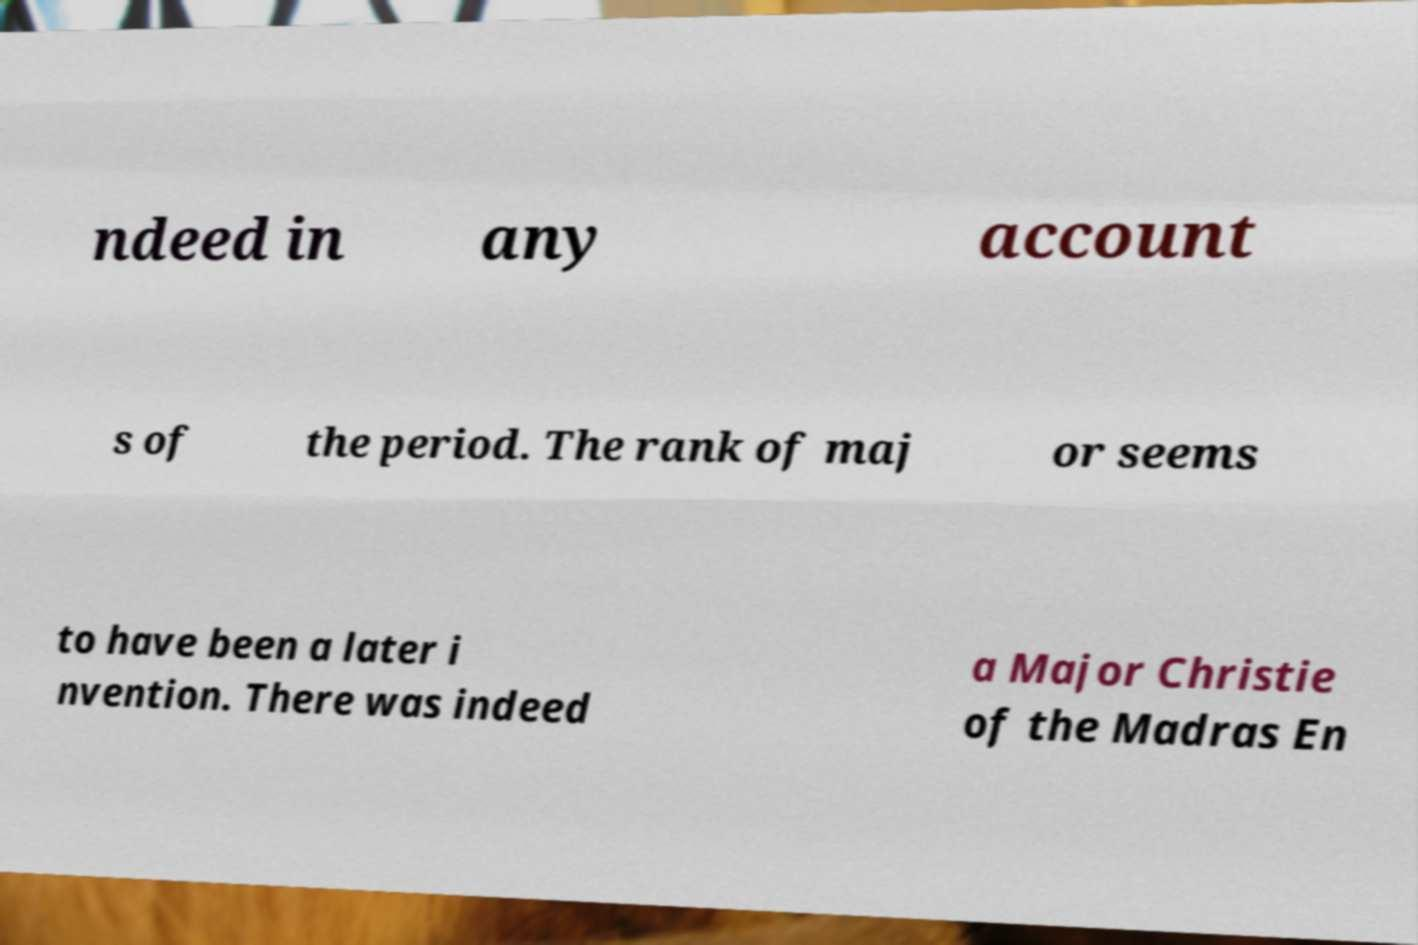Can you read and provide the text displayed in the image?This photo seems to have some interesting text. Can you extract and type it out for me? ndeed in any account s of the period. The rank of maj or seems to have been a later i nvention. There was indeed a Major Christie of the Madras En 